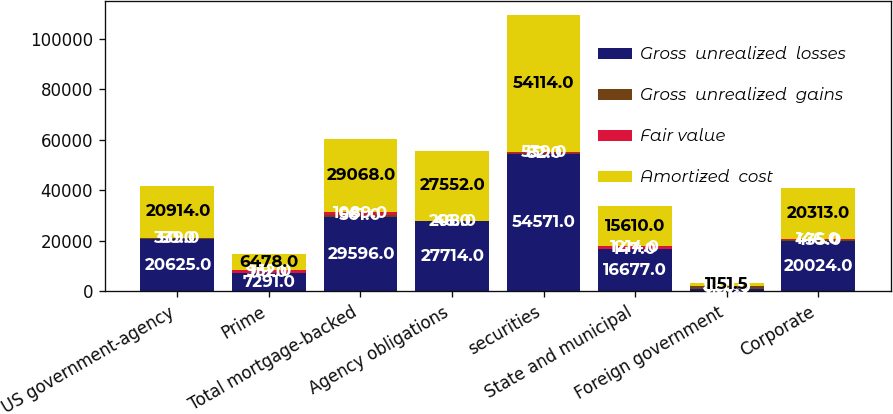Convert chart to OTSL. <chart><loc_0><loc_0><loc_500><loc_500><stacked_bar_chart><ecel><fcel>US government-agency<fcel>Prime<fcel>Total mortgage-backed<fcel>Agency obligations<fcel>securities<fcel>State and municipal<fcel>Foreign government<fcel>Corporate<nl><fcel>Gross  unrealized  losses<fcel>20625<fcel>7291<fcel>29596<fcel>27714<fcel>54571<fcel>16677<fcel>1151.5<fcel>20024<nl><fcel>Gross  unrealized  gains<fcel>339<fcel>119<fcel>561<fcel>46<fcel>82<fcel>147<fcel>860<fcel>435<nl><fcel>Fair value<fcel>50<fcel>932<fcel>1089<fcel>208<fcel>539<fcel>1214<fcel>328<fcel>146<nl><fcel>Amortized  cost<fcel>20914<fcel>6478<fcel>29068<fcel>27552<fcel>54114<fcel>15610<fcel>1151.5<fcel>20313<nl></chart> 